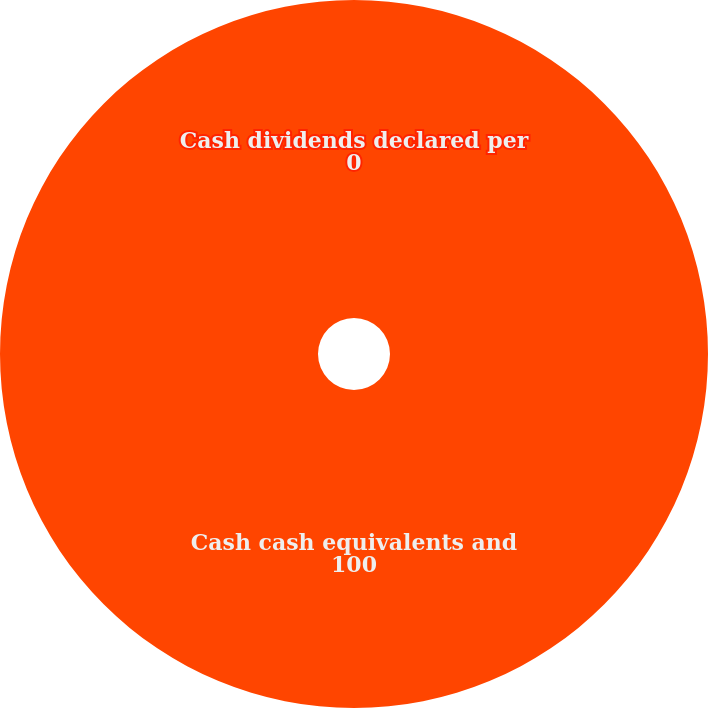Convert chart. <chart><loc_0><loc_0><loc_500><loc_500><pie_chart><fcel>Cash dividends declared per<fcel>Cash cash equivalents and<nl><fcel>0.0%<fcel>100.0%<nl></chart> 